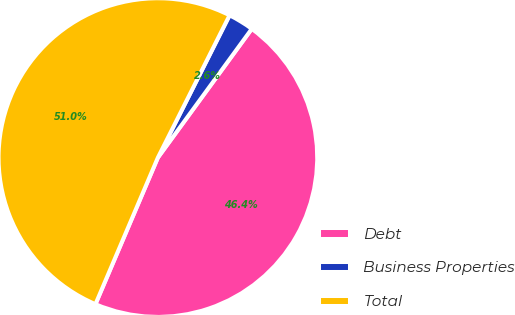Convert chart to OTSL. <chart><loc_0><loc_0><loc_500><loc_500><pie_chart><fcel>Debt<fcel>Business Properties<fcel>Total<nl><fcel>46.38%<fcel>2.6%<fcel>51.02%<nl></chart> 